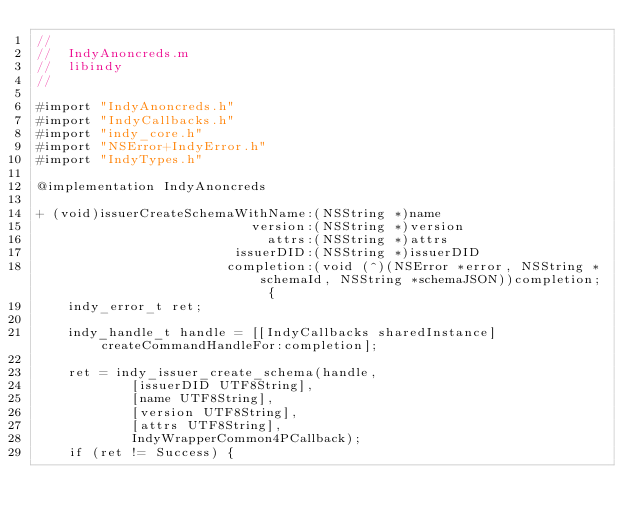Convert code to text. <code><loc_0><loc_0><loc_500><loc_500><_ObjectiveC_>//
//  IndyAnoncreds.m
//  libindy
//

#import "IndyAnoncreds.h"
#import "IndyCallbacks.h"
#import "indy_core.h"
#import "NSError+IndyError.h"
#import "IndyTypes.h"

@implementation IndyAnoncreds

+ (void)issuerCreateSchemaWithName:(NSString *)name
                           version:(NSString *)version
                             attrs:(NSString *)attrs
                         issuerDID:(NSString *)issuerDID
                        completion:(void (^)(NSError *error, NSString *schemaId, NSString *schemaJSON))completion; {
    indy_error_t ret;

    indy_handle_t handle = [[IndyCallbacks sharedInstance] createCommandHandleFor:completion];

    ret = indy_issuer_create_schema(handle,
            [issuerDID UTF8String],
            [name UTF8String],
            [version UTF8String],
            [attrs UTF8String],
            IndyWrapperCommon4PCallback);
    if (ret != Success) {</code> 